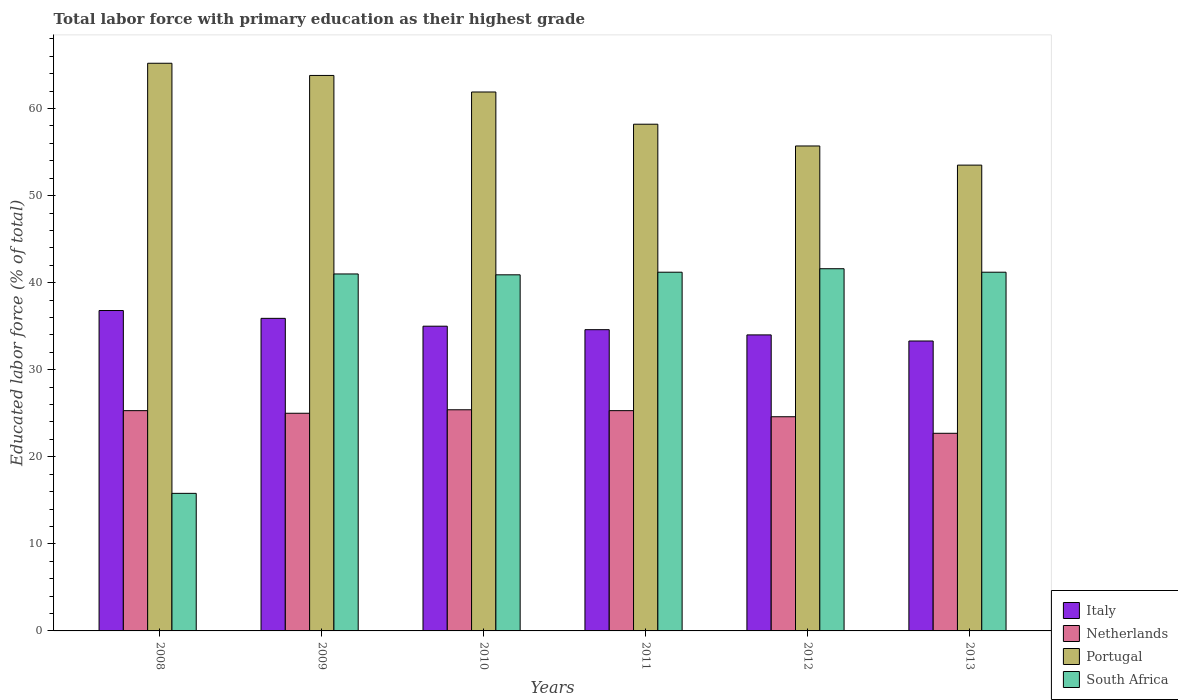How many different coloured bars are there?
Your answer should be very brief. 4. Are the number of bars per tick equal to the number of legend labels?
Make the answer very short. Yes. Are the number of bars on each tick of the X-axis equal?
Give a very brief answer. Yes. How many bars are there on the 2nd tick from the left?
Provide a short and direct response. 4. In how many cases, is the number of bars for a given year not equal to the number of legend labels?
Offer a very short reply. 0. What is the percentage of total labor force with primary education in South Africa in 2010?
Give a very brief answer. 40.9. Across all years, what is the maximum percentage of total labor force with primary education in Netherlands?
Provide a short and direct response. 25.4. Across all years, what is the minimum percentage of total labor force with primary education in Italy?
Give a very brief answer. 33.3. What is the total percentage of total labor force with primary education in Portugal in the graph?
Keep it short and to the point. 358.3. What is the difference between the percentage of total labor force with primary education in Netherlands in 2008 and that in 2011?
Provide a succinct answer. 0. What is the average percentage of total labor force with primary education in Netherlands per year?
Offer a terse response. 24.72. In the year 2012, what is the difference between the percentage of total labor force with primary education in South Africa and percentage of total labor force with primary education in Italy?
Provide a short and direct response. 7.6. What is the ratio of the percentage of total labor force with primary education in South Africa in 2010 to that in 2013?
Give a very brief answer. 0.99. Is the difference between the percentage of total labor force with primary education in South Africa in 2011 and 2013 greater than the difference between the percentage of total labor force with primary education in Italy in 2011 and 2013?
Your response must be concise. No. What is the difference between the highest and the second highest percentage of total labor force with primary education in Netherlands?
Keep it short and to the point. 0.1. What is the difference between the highest and the lowest percentage of total labor force with primary education in Portugal?
Give a very brief answer. 11.7. Is the sum of the percentage of total labor force with primary education in South Africa in 2009 and 2012 greater than the maximum percentage of total labor force with primary education in Italy across all years?
Give a very brief answer. Yes. What does the 4th bar from the right in 2012 represents?
Your answer should be compact. Italy. How many bars are there?
Make the answer very short. 24. Are all the bars in the graph horizontal?
Your response must be concise. No. What is the difference between two consecutive major ticks on the Y-axis?
Keep it short and to the point. 10. Does the graph contain any zero values?
Your answer should be compact. No. Does the graph contain grids?
Make the answer very short. No. How many legend labels are there?
Provide a succinct answer. 4. How are the legend labels stacked?
Offer a very short reply. Vertical. What is the title of the graph?
Your answer should be very brief. Total labor force with primary education as their highest grade. What is the label or title of the Y-axis?
Ensure brevity in your answer.  Educated labor force (% of total). What is the Educated labor force (% of total) in Italy in 2008?
Ensure brevity in your answer.  36.8. What is the Educated labor force (% of total) of Netherlands in 2008?
Offer a very short reply. 25.3. What is the Educated labor force (% of total) in Portugal in 2008?
Keep it short and to the point. 65.2. What is the Educated labor force (% of total) of South Africa in 2008?
Your answer should be very brief. 15.8. What is the Educated labor force (% of total) of Italy in 2009?
Ensure brevity in your answer.  35.9. What is the Educated labor force (% of total) in Portugal in 2009?
Offer a very short reply. 63.8. What is the Educated labor force (% of total) of Netherlands in 2010?
Offer a terse response. 25.4. What is the Educated labor force (% of total) of Portugal in 2010?
Provide a succinct answer. 61.9. What is the Educated labor force (% of total) of South Africa in 2010?
Provide a short and direct response. 40.9. What is the Educated labor force (% of total) of Italy in 2011?
Offer a very short reply. 34.6. What is the Educated labor force (% of total) in Netherlands in 2011?
Ensure brevity in your answer.  25.3. What is the Educated labor force (% of total) of Portugal in 2011?
Ensure brevity in your answer.  58.2. What is the Educated labor force (% of total) of South Africa in 2011?
Keep it short and to the point. 41.2. What is the Educated labor force (% of total) of Netherlands in 2012?
Ensure brevity in your answer.  24.6. What is the Educated labor force (% of total) in Portugal in 2012?
Your answer should be very brief. 55.7. What is the Educated labor force (% of total) in South Africa in 2012?
Give a very brief answer. 41.6. What is the Educated labor force (% of total) of Italy in 2013?
Keep it short and to the point. 33.3. What is the Educated labor force (% of total) in Netherlands in 2013?
Make the answer very short. 22.7. What is the Educated labor force (% of total) of Portugal in 2013?
Your response must be concise. 53.5. What is the Educated labor force (% of total) of South Africa in 2013?
Your response must be concise. 41.2. Across all years, what is the maximum Educated labor force (% of total) in Italy?
Your answer should be very brief. 36.8. Across all years, what is the maximum Educated labor force (% of total) of Netherlands?
Make the answer very short. 25.4. Across all years, what is the maximum Educated labor force (% of total) in Portugal?
Your answer should be very brief. 65.2. Across all years, what is the maximum Educated labor force (% of total) of South Africa?
Offer a terse response. 41.6. Across all years, what is the minimum Educated labor force (% of total) of Italy?
Make the answer very short. 33.3. Across all years, what is the minimum Educated labor force (% of total) in Netherlands?
Your answer should be compact. 22.7. Across all years, what is the minimum Educated labor force (% of total) in Portugal?
Offer a terse response. 53.5. Across all years, what is the minimum Educated labor force (% of total) of South Africa?
Your answer should be compact. 15.8. What is the total Educated labor force (% of total) in Italy in the graph?
Your response must be concise. 209.6. What is the total Educated labor force (% of total) in Netherlands in the graph?
Make the answer very short. 148.3. What is the total Educated labor force (% of total) of Portugal in the graph?
Offer a very short reply. 358.3. What is the total Educated labor force (% of total) in South Africa in the graph?
Offer a terse response. 221.7. What is the difference between the Educated labor force (% of total) in Italy in 2008 and that in 2009?
Ensure brevity in your answer.  0.9. What is the difference between the Educated labor force (% of total) in Netherlands in 2008 and that in 2009?
Keep it short and to the point. 0.3. What is the difference between the Educated labor force (% of total) in South Africa in 2008 and that in 2009?
Keep it short and to the point. -25.2. What is the difference between the Educated labor force (% of total) of Italy in 2008 and that in 2010?
Give a very brief answer. 1.8. What is the difference between the Educated labor force (% of total) of Portugal in 2008 and that in 2010?
Offer a terse response. 3.3. What is the difference between the Educated labor force (% of total) in South Africa in 2008 and that in 2010?
Ensure brevity in your answer.  -25.1. What is the difference between the Educated labor force (% of total) in Italy in 2008 and that in 2011?
Make the answer very short. 2.2. What is the difference between the Educated labor force (% of total) in Netherlands in 2008 and that in 2011?
Offer a very short reply. 0. What is the difference between the Educated labor force (% of total) of South Africa in 2008 and that in 2011?
Your response must be concise. -25.4. What is the difference between the Educated labor force (% of total) in Netherlands in 2008 and that in 2012?
Provide a short and direct response. 0.7. What is the difference between the Educated labor force (% of total) of South Africa in 2008 and that in 2012?
Give a very brief answer. -25.8. What is the difference between the Educated labor force (% of total) of Italy in 2008 and that in 2013?
Offer a terse response. 3.5. What is the difference between the Educated labor force (% of total) in Netherlands in 2008 and that in 2013?
Offer a very short reply. 2.6. What is the difference between the Educated labor force (% of total) in Portugal in 2008 and that in 2013?
Ensure brevity in your answer.  11.7. What is the difference between the Educated labor force (% of total) of South Africa in 2008 and that in 2013?
Your answer should be compact. -25.4. What is the difference between the Educated labor force (% of total) in Italy in 2009 and that in 2010?
Provide a short and direct response. 0.9. What is the difference between the Educated labor force (% of total) in Netherlands in 2009 and that in 2010?
Offer a very short reply. -0.4. What is the difference between the Educated labor force (% of total) of Portugal in 2009 and that in 2010?
Keep it short and to the point. 1.9. What is the difference between the Educated labor force (% of total) in South Africa in 2009 and that in 2010?
Ensure brevity in your answer.  0.1. What is the difference between the Educated labor force (% of total) in South Africa in 2009 and that in 2011?
Give a very brief answer. -0.2. What is the difference between the Educated labor force (% of total) of Portugal in 2009 and that in 2012?
Provide a short and direct response. 8.1. What is the difference between the Educated labor force (% of total) of South Africa in 2009 and that in 2012?
Your answer should be compact. -0.6. What is the difference between the Educated labor force (% of total) of Netherlands in 2009 and that in 2013?
Give a very brief answer. 2.3. What is the difference between the Educated labor force (% of total) in South Africa in 2009 and that in 2013?
Your answer should be very brief. -0.2. What is the difference between the Educated labor force (% of total) of Italy in 2010 and that in 2011?
Keep it short and to the point. 0.4. What is the difference between the Educated labor force (% of total) in South Africa in 2010 and that in 2011?
Ensure brevity in your answer.  -0.3. What is the difference between the Educated labor force (% of total) in Italy in 2010 and that in 2013?
Offer a very short reply. 1.7. What is the difference between the Educated labor force (% of total) in Netherlands in 2010 and that in 2013?
Your answer should be compact. 2.7. What is the difference between the Educated labor force (% of total) of South Africa in 2010 and that in 2013?
Your answer should be very brief. -0.3. What is the difference between the Educated labor force (% of total) in Netherlands in 2011 and that in 2012?
Provide a succinct answer. 0.7. What is the difference between the Educated labor force (% of total) in Italy in 2011 and that in 2013?
Offer a terse response. 1.3. What is the difference between the Educated labor force (% of total) in Portugal in 2011 and that in 2013?
Your answer should be very brief. 4.7. What is the difference between the Educated labor force (% of total) in South Africa in 2011 and that in 2013?
Your response must be concise. 0. What is the difference between the Educated labor force (% of total) in Italy in 2012 and that in 2013?
Give a very brief answer. 0.7. What is the difference between the Educated labor force (% of total) in Italy in 2008 and the Educated labor force (% of total) in Portugal in 2009?
Offer a terse response. -27. What is the difference between the Educated labor force (% of total) of Netherlands in 2008 and the Educated labor force (% of total) of Portugal in 2009?
Offer a terse response. -38.5. What is the difference between the Educated labor force (% of total) of Netherlands in 2008 and the Educated labor force (% of total) of South Africa in 2009?
Your response must be concise. -15.7. What is the difference between the Educated labor force (% of total) in Portugal in 2008 and the Educated labor force (% of total) in South Africa in 2009?
Your answer should be very brief. 24.2. What is the difference between the Educated labor force (% of total) of Italy in 2008 and the Educated labor force (% of total) of Netherlands in 2010?
Offer a very short reply. 11.4. What is the difference between the Educated labor force (% of total) of Italy in 2008 and the Educated labor force (% of total) of Portugal in 2010?
Your answer should be compact. -25.1. What is the difference between the Educated labor force (% of total) of Italy in 2008 and the Educated labor force (% of total) of South Africa in 2010?
Keep it short and to the point. -4.1. What is the difference between the Educated labor force (% of total) of Netherlands in 2008 and the Educated labor force (% of total) of Portugal in 2010?
Offer a terse response. -36.6. What is the difference between the Educated labor force (% of total) in Netherlands in 2008 and the Educated labor force (% of total) in South Africa in 2010?
Ensure brevity in your answer.  -15.6. What is the difference between the Educated labor force (% of total) in Portugal in 2008 and the Educated labor force (% of total) in South Africa in 2010?
Provide a succinct answer. 24.3. What is the difference between the Educated labor force (% of total) of Italy in 2008 and the Educated labor force (% of total) of Portugal in 2011?
Offer a terse response. -21.4. What is the difference between the Educated labor force (% of total) in Italy in 2008 and the Educated labor force (% of total) in South Africa in 2011?
Your answer should be very brief. -4.4. What is the difference between the Educated labor force (% of total) in Netherlands in 2008 and the Educated labor force (% of total) in Portugal in 2011?
Your answer should be compact. -32.9. What is the difference between the Educated labor force (% of total) in Netherlands in 2008 and the Educated labor force (% of total) in South Africa in 2011?
Offer a very short reply. -15.9. What is the difference between the Educated labor force (% of total) in Italy in 2008 and the Educated labor force (% of total) in Netherlands in 2012?
Keep it short and to the point. 12.2. What is the difference between the Educated labor force (% of total) in Italy in 2008 and the Educated labor force (% of total) in Portugal in 2012?
Ensure brevity in your answer.  -18.9. What is the difference between the Educated labor force (% of total) of Netherlands in 2008 and the Educated labor force (% of total) of Portugal in 2012?
Your answer should be very brief. -30.4. What is the difference between the Educated labor force (% of total) of Netherlands in 2008 and the Educated labor force (% of total) of South Africa in 2012?
Offer a terse response. -16.3. What is the difference between the Educated labor force (% of total) in Portugal in 2008 and the Educated labor force (% of total) in South Africa in 2012?
Provide a succinct answer. 23.6. What is the difference between the Educated labor force (% of total) of Italy in 2008 and the Educated labor force (% of total) of Netherlands in 2013?
Your answer should be very brief. 14.1. What is the difference between the Educated labor force (% of total) in Italy in 2008 and the Educated labor force (% of total) in Portugal in 2013?
Keep it short and to the point. -16.7. What is the difference between the Educated labor force (% of total) of Netherlands in 2008 and the Educated labor force (% of total) of Portugal in 2013?
Provide a succinct answer. -28.2. What is the difference between the Educated labor force (% of total) of Netherlands in 2008 and the Educated labor force (% of total) of South Africa in 2013?
Keep it short and to the point. -15.9. What is the difference between the Educated labor force (% of total) in Italy in 2009 and the Educated labor force (% of total) in Netherlands in 2010?
Give a very brief answer. 10.5. What is the difference between the Educated labor force (% of total) of Italy in 2009 and the Educated labor force (% of total) of South Africa in 2010?
Your answer should be very brief. -5. What is the difference between the Educated labor force (% of total) in Netherlands in 2009 and the Educated labor force (% of total) in Portugal in 2010?
Make the answer very short. -36.9. What is the difference between the Educated labor force (% of total) of Netherlands in 2009 and the Educated labor force (% of total) of South Africa in 2010?
Offer a very short reply. -15.9. What is the difference between the Educated labor force (% of total) of Portugal in 2009 and the Educated labor force (% of total) of South Africa in 2010?
Give a very brief answer. 22.9. What is the difference between the Educated labor force (% of total) of Italy in 2009 and the Educated labor force (% of total) of Portugal in 2011?
Offer a very short reply. -22.3. What is the difference between the Educated labor force (% of total) in Italy in 2009 and the Educated labor force (% of total) in South Africa in 2011?
Make the answer very short. -5.3. What is the difference between the Educated labor force (% of total) of Netherlands in 2009 and the Educated labor force (% of total) of Portugal in 2011?
Give a very brief answer. -33.2. What is the difference between the Educated labor force (% of total) of Netherlands in 2009 and the Educated labor force (% of total) of South Africa in 2011?
Keep it short and to the point. -16.2. What is the difference between the Educated labor force (% of total) of Portugal in 2009 and the Educated labor force (% of total) of South Africa in 2011?
Provide a short and direct response. 22.6. What is the difference between the Educated labor force (% of total) of Italy in 2009 and the Educated labor force (% of total) of Portugal in 2012?
Your response must be concise. -19.8. What is the difference between the Educated labor force (% of total) of Netherlands in 2009 and the Educated labor force (% of total) of Portugal in 2012?
Provide a succinct answer. -30.7. What is the difference between the Educated labor force (% of total) of Netherlands in 2009 and the Educated labor force (% of total) of South Africa in 2012?
Offer a very short reply. -16.6. What is the difference between the Educated labor force (% of total) of Portugal in 2009 and the Educated labor force (% of total) of South Africa in 2012?
Make the answer very short. 22.2. What is the difference between the Educated labor force (% of total) of Italy in 2009 and the Educated labor force (% of total) of Netherlands in 2013?
Keep it short and to the point. 13.2. What is the difference between the Educated labor force (% of total) of Italy in 2009 and the Educated labor force (% of total) of Portugal in 2013?
Make the answer very short. -17.6. What is the difference between the Educated labor force (% of total) of Netherlands in 2009 and the Educated labor force (% of total) of Portugal in 2013?
Your answer should be compact. -28.5. What is the difference between the Educated labor force (% of total) in Netherlands in 2009 and the Educated labor force (% of total) in South Africa in 2013?
Offer a terse response. -16.2. What is the difference between the Educated labor force (% of total) of Portugal in 2009 and the Educated labor force (% of total) of South Africa in 2013?
Make the answer very short. 22.6. What is the difference between the Educated labor force (% of total) of Italy in 2010 and the Educated labor force (% of total) of Netherlands in 2011?
Offer a terse response. 9.7. What is the difference between the Educated labor force (% of total) of Italy in 2010 and the Educated labor force (% of total) of Portugal in 2011?
Keep it short and to the point. -23.2. What is the difference between the Educated labor force (% of total) of Netherlands in 2010 and the Educated labor force (% of total) of Portugal in 2011?
Provide a succinct answer. -32.8. What is the difference between the Educated labor force (% of total) in Netherlands in 2010 and the Educated labor force (% of total) in South Africa in 2011?
Make the answer very short. -15.8. What is the difference between the Educated labor force (% of total) in Portugal in 2010 and the Educated labor force (% of total) in South Africa in 2011?
Keep it short and to the point. 20.7. What is the difference between the Educated labor force (% of total) of Italy in 2010 and the Educated labor force (% of total) of Portugal in 2012?
Ensure brevity in your answer.  -20.7. What is the difference between the Educated labor force (% of total) of Netherlands in 2010 and the Educated labor force (% of total) of Portugal in 2012?
Your answer should be compact. -30.3. What is the difference between the Educated labor force (% of total) in Netherlands in 2010 and the Educated labor force (% of total) in South Africa in 2012?
Ensure brevity in your answer.  -16.2. What is the difference between the Educated labor force (% of total) in Portugal in 2010 and the Educated labor force (% of total) in South Africa in 2012?
Give a very brief answer. 20.3. What is the difference between the Educated labor force (% of total) of Italy in 2010 and the Educated labor force (% of total) of Netherlands in 2013?
Give a very brief answer. 12.3. What is the difference between the Educated labor force (% of total) in Italy in 2010 and the Educated labor force (% of total) in Portugal in 2013?
Offer a very short reply. -18.5. What is the difference between the Educated labor force (% of total) in Italy in 2010 and the Educated labor force (% of total) in South Africa in 2013?
Give a very brief answer. -6.2. What is the difference between the Educated labor force (% of total) of Netherlands in 2010 and the Educated labor force (% of total) of Portugal in 2013?
Provide a succinct answer. -28.1. What is the difference between the Educated labor force (% of total) in Netherlands in 2010 and the Educated labor force (% of total) in South Africa in 2013?
Keep it short and to the point. -15.8. What is the difference between the Educated labor force (% of total) in Portugal in 2010 and the Educated labor force (% of total) in South Africa in 2013?
Provide a succinct answer. 20.7. What is the difference between the Educated labor force (% of total) of Italy in 2011 and the Educated labor force (% of total) of Netherlands in 2012?
Provide a short and direct response. 10. What is the difference between the Educated labor force (% of total) in Italy in 2011 and the Educated labor force (% of total) in Portugal in 2012?
Your answer should be very brief. -21.1. What is the difference between the Educated labor force (% of total) of Netherlands in 2011 and the Educated labor force (% of total) of Portugal in 2012?
Offer a very short reply. -30.4. What is the difference between the Educated labor force (% of total) of Netherlands in 2011 and the Educated labor force (% of total) of South Africa in 2012?
Provide a succinct answer. -16.3. What is the difference between the Educated labor force (% of total) in Portugal in 2011 and the Educated labor force (% of total) in South Africa in 2012?
Provide a short and direct response. 16.6. What is the difference between the Educated labor force (% of total) in Italy in 2011 and the Educated labor force (% of total) in Netherlands in 2013?
Keep it short and to the point. 11.9. What is the difference between the Educated labor force (% of total) in Italy in 2011 and the Educated labor force (% of total) in Portugal in 2013?
Make the answer very short. -18.9. What is the difference between the Educated labor force (% of total) of Italy in 2011 and the Educated labor force (% of total) of South Africa in 2013?
Ensure brevity in your answer.  -6.6. What is the difference between the Educated labor force (% of total) in Netherlands in 2011 and the Educated labor force (% of total) in Portugal in 2013?
Provide a short and direct response. -28.2. What is the difference between the Educated labor force (% of total) in Netherlands in 2011 and the Educated labor force (% of total) in South Africa in 2013?
Make the answer very short. -15.9. What is the difference between the Educated labor force (% of total) in Italy in 2012 and the Educated labor force (% of total) in Portugal in 2013?
Offer a very short reply. -19.5. What is the difference between the Educated labor force (% of total) in Netherlands in 2012 and the Educated labor force (% of total) in Portugal in 2013?
Provide a succinct answer. -28.9. What is the difference between the Educated labor force (% of total) in Netherlands in 2012 and the Educated labor force (% of total) in South Africa in 2013?
Offer a terse response. -16.6. What is the average Educated labor force (% of total) in Italy per year?
Offer a very short reply. 34.93. What is the average Educated labor force (% of total) in Netherlands per year?
Offer a very short reply. 24.72. What is the average Educated labor force (% of total) in Portugal per year?
Keep it short and to the point. 59.72. What is the average Educated labor force (% of total) of South Africa per year?
Offer a very short reply. 36.95. In the year 2008, what is the difference between the Educated labor force (% of total) in Italy and Educated labor force (% of total) in Netherlands?
Keep it short and to the point. 11.5. In the year 2008, what is the difference between the Educated labor force (% of total) in Italy and Educated labor force (% of total) in Portugal?
Your answer should be very brief. -28.4. In the year 2008, what is the difference between the Educated labor force (% of total) in Netherlands and Educated labor force (% of total) in Portugal?
Your answer should be very brief. -39.9. In the year 2008, what is the difference between the Educated labor force (% of total) of Portugal and Educated labor force (% of total) of South Africa?
Give a very brief answer. 49.4. In the year 2009, what is the difference between the Educated labor force (% of total) in Italy and Educated labor force (% of total) in Portugal?
Your answer should be very brief. -27.9. In the year 2009, what is the difference between the Educated labor force (% of total) in Italy and Educated labor force (% of total) in South Africa?
Offer a terse response. -5.1. In the year 2009, what is the difference between the Educated labor force (% of total) in Netherlands and Educated labor force (% of total) in Portugal?
Your response must be concise. -38.8. In the year 2009, what is the difference between the Educated labor force (% of total) of Netherlands and Educated labor force (% of total) of South Africa?
Your answer should be compact. -16. In the year 2009, what is the difference between the Educated labor force (% of total) of Portugal and Educated labor force (% of total) of South Africa?
Offer a terse response. 22.8. In the year 2010, what is the difference between the Educated labor force (% of total) of Italy and Educated labor force (% of total) of Portugal?
Keep it short and to the point. -26.9. In the year 2010, what is the difference between the Educated labor force (% of total) in Netherlands and Educated labor force (% of total) in Portugal?
Offer a very short reply. -36.5. In the year 2010, what is the difference between the Educated labor force (% of total) of Netherlands and Educated labor force (% of total) of South Africa?
Your response must be concise. -15.5. In the year 2010, what is the difference between the Educated labor force (% of total) of Portugal and Educated labor force (% of total) of South Africa?
Keep it short and to the point. 21. In the year 2011, what is the difference between the Educated labor force (% of total) in Italy and Educated labor force (% of total) in Portugal?
Provide a short and direct response. -23.6. In the year 2011, what is the difference between the Educated labor force (% of total) in Italy and Educated labor force (% of total) in South Africa?
Offer a terse response. -6.6. In the year 2011, what is the difference between the Educated labor force (% of total) in Netherlands and Educated labor force (% of total) in Portugal?
Provide a succinct answer. -32.9. In the year 2011, what is the difference between the Educated labor force (% of total) in Netherlands and Educated labor force (% of total) in South Africa?
Your answer should be very brief. -15.9. In the year 2011, what is the difference between the Educated labor force (% of total) of Portugal and Educated labor force (% of total) of South Africa?
Keep it short and to the point. 17. In the year 2012, what is the difference between the Educated labor force (% of total) of Italy and Educated labor force (% of total) of Portugal?
Offer a terse response. -21.7. In the year 2012, what is the difference between the Educated labor force (% of total) in Italy and Educated labor force (% of total) in South Africa?
Provide a succinct answer. -7.6. In the year 2012, what is the difference between the Educated labor force (% of total) in Netherlands and Educated labor force (% of total) in Portugal?
Ensure brevity in your answer.  -31.1. In the year 2012, what is the difference between the Educated labor force (% of total) of Portugal and Educated labor force (% of total) of South Africa?
Provide a short and direct response. 14.1. In the year 2013, what is the difference between the Educated labor force (% of total) of Italy and Educated labor force (% of total) of Netherlands?
Your answer should be compact. 10.6. In the year 2013, what is the difference between the Educated labor force (% of total) of Italy and Educated labor force (% of total) of Portugal?
Offer a terse response. -20.2. In the year 2013, what is the difference between the Educated labor force (% of total) of Netherlands and Educated labor force (% of total) of Portugal?
Your answer should be compact. -30.8. In the year 2013, what is the difference between the Educated labor force (% of total) of Netherlands and Educated labor force (% of total) of South Africa?
Keep it short and to the point. -18.5. What is the ratio of the Educated labor force (% of total) in Italy in 2008 to that in 2009?
Your response must be concise. 1.03. What is the ratio of the Educated labor force (% of total) in Portugal in 2008 to that in 2009?
Offer a very short reply. 1.02. What is the ratio of the Educated labor force (% of total) of South Africa in 2008 to that in 2009?
Your answer should be very brief. 0.39. What is the ratio of the Educated labor force (% of total) in Italy in 2008 to that in 2010?
Provide a succinct answer. 1.05. What is the ratio of the Educated labor force (% of total) of Netherlands in 2008 to that in 2010?
Your response must be concise. 1. What is the ratio of the Educated labor force (% of total) in Portugal in 2008 to that in 2010?
Ensure brevity in your answer.  1.05. What is the ratio of the Educated labor force (% of total) in South Africa in 2008 to that in 2010?
Offer a very short reply. 0.39. What is the ratio of the Educated labor force (% of total) of Italy in 2008 to that in 2011?
Provide a succinct answer. 1.06. What is the ratio of the Educated labor force (% of total) in Portugal in 2008 to that in 2011?
Keep it short and to the point. 1.12. What is the ratio of the Educated labor force (% of total) of South Africa in 2008 to that in 2011?
Give a very brief answer. 0.38. What is the ratio of the Educated labor force (% of total) in Italy in 2008 to that in 2012?
Your response must be concise. 1.08. What is the ratio of the Educated labor force (% of total) in Netherlands in 2008 to that in 2012?
Your response must be concise. 1.03. What is the ratio of the Educated labor force (% of total) in Portugal in 2008 to that in 2012?
Your answer should be very brief. 1.17. What is the ratio of the Educated labor force (% of total) in South Africa in 2008 to that in 2012?
Offer a terse response. 0.38. What is the ratio of the Educated labor force (% of total) of Italy in 2008 to that in 2013?
Your answer should be very brief. 1.11. What is the ratio of the Educated labor force (% of total) of Netherlands in 2008 to that in 2013?
Give a very brief answer. 1.11. What is the ratio of the Educated labor force (% of total) in Portugal in 2008 to that in 2013?
Your response must be concise. 1.22. What is the ratio of the Educated labor force (% of total) of South Africa in 2008 to that in 2013?
Your answer should be very brief. 0.38. What is the ratio of the Educated labor force (% of total) in Italy in 2009 to that in 2010?
Ensure brevity in your answer.  1.03. What is the ratio of the Educated labor force (% of total) in Netherlands in 2009 to that in 2010?
Keep it short and to the point. 0.98. What is the ratio of the Educated labor force (% of total) of Portugal in 2009 to that in 2010?
Provide a short and direct response. 1.03. What is the ratio of the Educated labor force (% of total) in South Africa in 2009 to that in 2010?
Provide a succinct answer. 1. What is the ratio of the Educated labor force (% of total) in Italy in 2009 to that in 2011?
Make the answer very short. 1.04. What is the ratio of the Educated labor force (% of total) in Portugal in 2009 to that in 2011?
Provide a short and direct response. 1.1. What is the ratio of the Educated labor force (% of total) of Italy in 2009 to that in 2012?
Provide a succinct answer. 1.06. What is the ratio of the Educated labor force (% of total) of Netherlands in 2009 to that in 2012?
Give a very brief answer. 1.02. What is the ratio of the Educated labor force (% of total) of Portugal in 2009 to that in 2012?
Your answer should be very brief. 1.15. What is the ratio of the Educated labor force (% of total) in South Africa in 2009 to that in 2012?
Provide a short and direct response. 0.99. What is the ratio of the Educated labor force (% of total) of Italy in 2009 to that in 2013?
Keep it short and to the point. 1.08. What is the ratio of the Educated labor force (% of total) of Netherlands in 2009 to that in 2013?
Make the answer very short. 1.1. What is the ratio of the Educated labor force (% of total) of Portugal in 2009 to that in 2013?
Provide a succinct answer. 1.19. What is the ratio of the Educated labor force (% of total) in South Africa in 2009 to that in 2013?
Give a very brief answer. 1. What is the ratio of the Educated labor force (% of total) of Italy in 2010 to that in 2011?
Provide a succinct answer. 1.01. What is the ratio of the Educated labor force (% of total) of Netherlands in 2010 to that in 2011?
Keep it short and to the point. 1. What is the ratio of the Educated labor force (% of total) of Portugal in 2010 to that in 2011?
Provide a succinct answer. 1.06. What is the ratio of the Educated labor force (% of total) in Italy in 2010 to that in 2012?
Your answer should be very brief. 1.03. What is the ratio of the Educated labor force (% of total) in Netherlands in 2010 to that in 2012?
Your response must be concise. 1.03. What is the ratio of the Educated labor force (% of total) in Portugal in 2010 to that in 2012?
Keep it short and to the point. 1.11. What is the ratio of the Educated labor force (% of total) of South Africa in 2010 to that in 2012?
Give a very brief answer. 0.98. What is the ratio of the Educated labor force (% of total) of Italy in 2010 to that in 2013?
Your answer should be compact. 1.05. What is the ratio of the Educated labor force (% of total) of Netherlands in 2010 to that in 2013?
Provide a succinct answer. 1.12. What is the ratio of the Educated labor force (% of total) in Portugal in 2010 to that in 2013?
Provide a short and direct response. 1.16. What is the ratio of the Educated labor force (% of total) in South Africa in 2010 to that in 2013?
Your answer should be compact. 0.99. What is the ratio of the Educated labor force (% of total) in Italy in 2011 to that in 2012?
Offer a very short reply. 1.02. What is the ratio of the Educated labor force (% of total) in Netherlands in 2011 to that in 2012?
Your answer should be very brief. 1.03. What is the ratio of the Educated labor force (% of total) of Portugal in 2011 to that in 2012?
Keep it short and to the point. 1.04. What is the ratio of the Educated labor force (% of total) of South Africa in 2011 to that in 2012?
Your response must be concise. 0.99. What is the ratio of the Educated labor force (% of total) of Italy in 2011 to that in 2013?
Make the answer very short. 1.04. What is the ratio of the Educated labor force (% of total) in Netherlands in 2011 to that in 2013?
Your answer should be compact. 1.11. What is the ratio of the Educated labor force (% of total) in Portugal in 2011 to that in 2013?
Provide a succinct answer. 1.09. What is the ratio of the Educated labor force (% of total) of South Africa in 2011 to that in 2013?
Make the answer very short. 1. What is the ratio of the Educated labor force (% of total) in Netherlands in 2012 to that in 2013?
Keep it short and to the point. 1.08. What is the ratio of the Educated labor force (% of total) of Portugal in 2012 to that in 2013?
Keep it short and to the point. 1.04. What is the ratio of the Educated labor force (% of total) in South Africa in 2012 to that in 2013?
Ensure brevity in your answer.  1.01. What is the difference between the highest and the second highest Educated labor force (% of total) in Netherlands?
Make the answer very short. 0.1. What is the difference between the highest and the second highest Educated labor force (% of total) of Portugal?
Offer a very short reply. 1.4. What is the difference between the highest and the second highest Educated labor force (% of total) in South Africa?
Your response must be concise. 0.4. What is the difference between the highest and the lowest Educated labor force (% of total) in Netherlands?
Offer a terse response. 2.7. What is the difference between the highest and the lowest Educated labor force (% of total) of Portugal?
Your answer should be very brief. 11.7. What is the difference between the highest and the lowest Educated labor force (% of total) of South Africa?
Your answer should be compact. 25.8. 